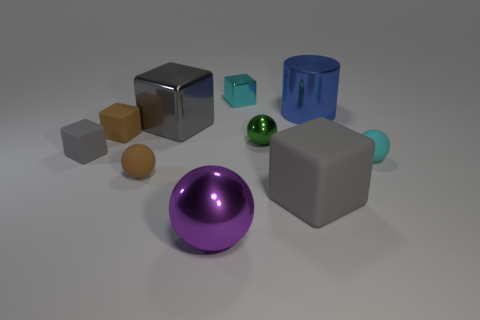Are there any other things of the same color as the small metallic ball?
Provide a short and direct response. No. There is a matte object that is left of the big blue thing and on the right side of the large gray metallic object; what is its color?
Give a very brief answer. Gray. There is a matte thing that is on the right side of the blue object; how big is it?
Give a very brief answer. Small. What number of tiny blue cylinders have the same material as the small cyan block?
Your answer should be compact. 0. What is the shape of the big object that is the same color as the large metal block?
Ensure brevity in your answer.  Cube. There is a gray matte object to the right of the brown rubber cube; does it have the same shape as the blue shiny thing?
Provide a succinct answer. No. The big block that is made of the same material as the blue thing is what color?
Provide a short and direct response. Gray. There is a tiny brown rubber thing that is in front of the small rubber ball that is to the right of the green shiny thing; are there any blocks that are in front of it?
Ensure brevity in your answer.  Yes. The tiny cyan shiny thing has what shape?
Offer a very short reply. Cube. Are there fewer small brown rubber objects behind the small green thing than big purple matte cubes?
Give a very brief answer. No. 